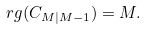Convert formula to latex. <formula><loc_0><loc_0><loc_500><loc_500>\ r g ( C _ { M | M - 1 } ) = M .</formula> 